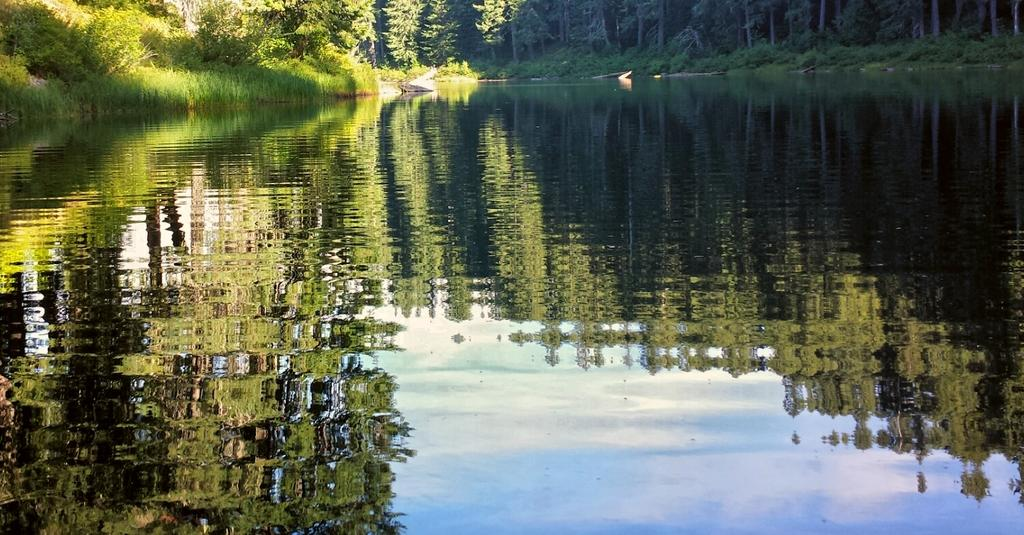What is the main subject in the center of the image? There is water in the center of the image. What can be observed about the water in the image? The water reflects the trees. What type of vegetation can be seen in the background of the image? There are trees and plants in the background of the image. What else is present in the background of the image? There is a boat and more water visible in the background. How many brothers are standing on the boat in the image? There are no brothers or boat present in the image; it features water and trees. What is the position of the moon in the image? There is no moon present in the image. 